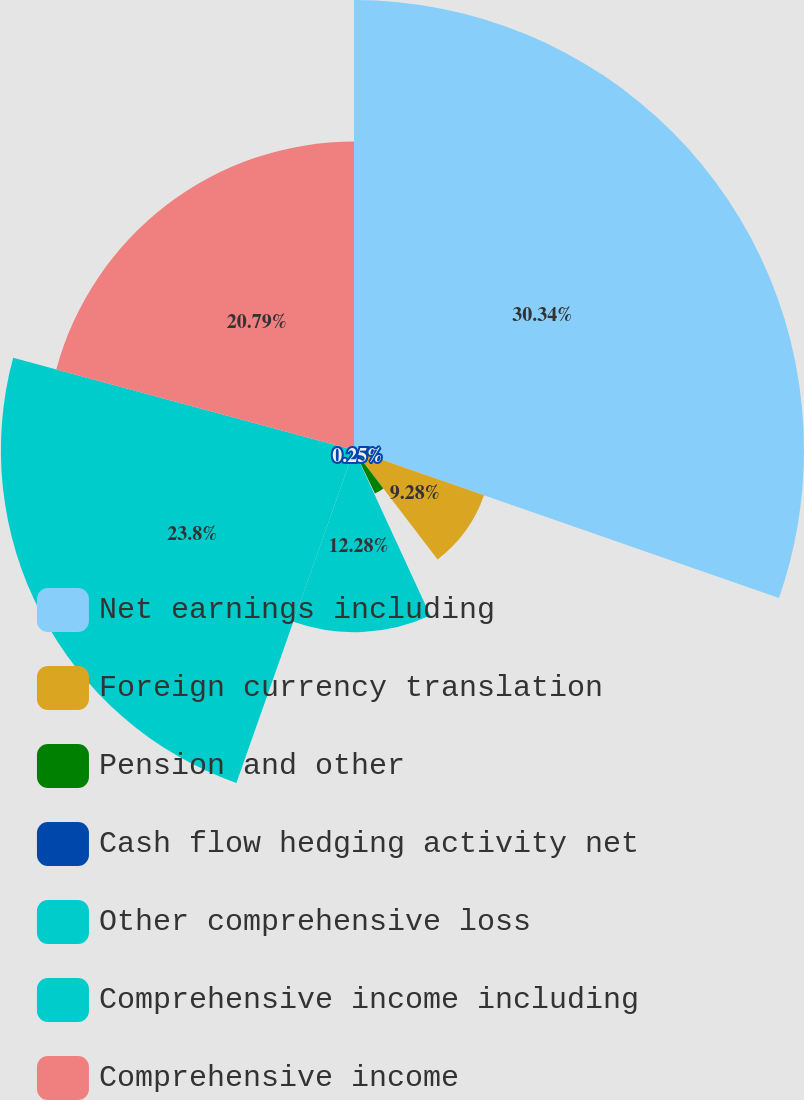Convert chart. <chart><loc_0><loc_0><loc_500><loc_500><pie_chart><fcel>Net earnings including<fcel>Foreign currency translation<fcel>Pension and other<fcel>Cash flow hedging activity net<fcel>Other comprehensive loss<fcel>Comprehensive income including<fcel>Comprehensive income<nl><fcel>30.33%<fcel>9.28%<fcel>3.26%<fcel>0.25%<fcel>12.28%<fcel>23.8%<fcel>20.79%<nl></chart> 